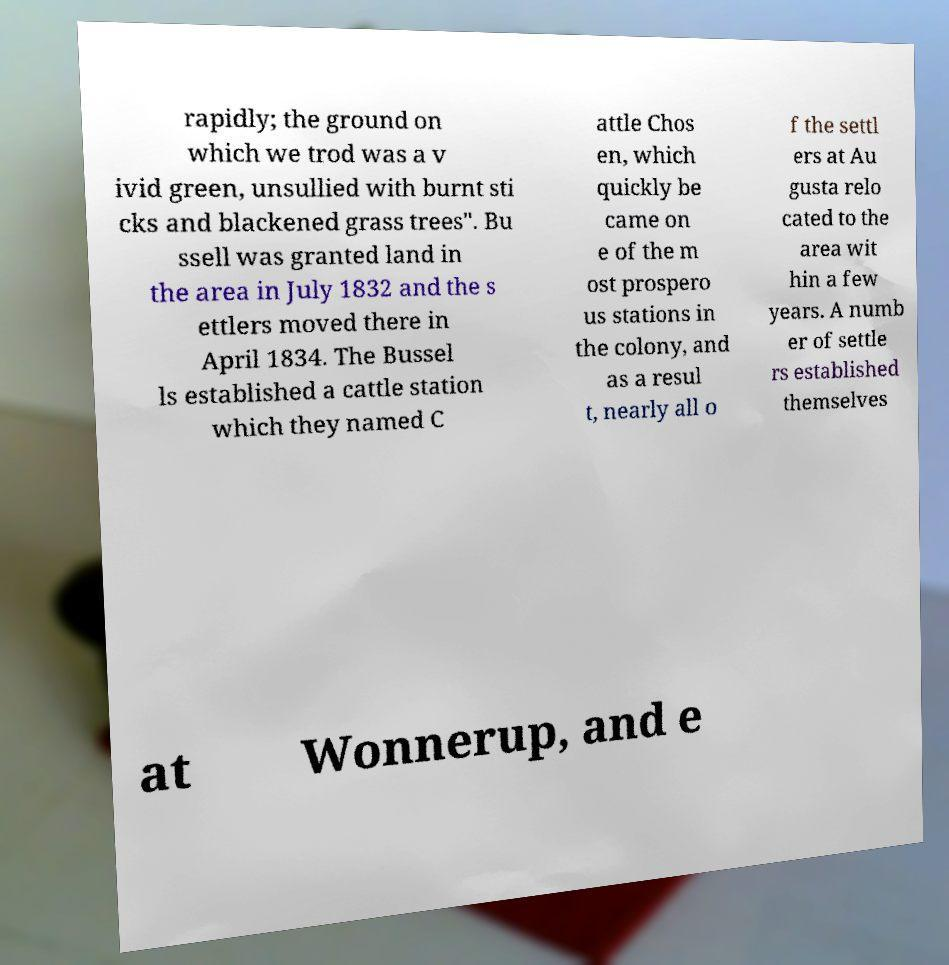Could you assist in decoding the text presented in this image and type it out clearly? rapidly; the ground on which we trod was a v ivid green, unsullied with burnt sti cks and blackened grass trees". Bu ssell was granted land in the area in July 1832 and the s ettlers moved there in April 1834. The Bussel ls established a cattle station which they named C attle Chos en, which quickly be came on e of the m ost prospero us stations in the colony, and as a resul t, nearly all o f the settl ers at Au gusta relo cated to the area wit hin a few years. A numb er of settle rs established themselves at Wonnerup, and e 